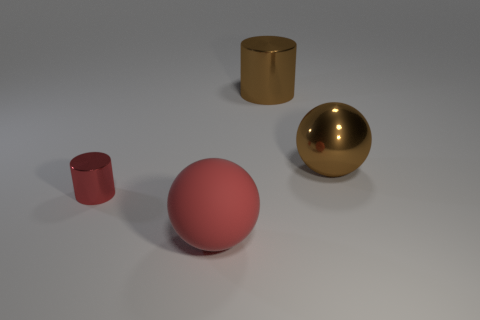Add 4 red spheres. How many objects exist? 8 Subtract all red cylinders. How many cylinders are left? 1 Subtract 1 cylinders. How many cylinders are left? 1 Subtract all brown spheres. Subtract all cyan blocks. How many spheres are left? 1 Subtract all green cylinders. How many green spheres are left? 0 Subtract all big purple objects. Subtract all red things. How many objects are left? 2 Add 1 big cylinders. How many big cylinders are left? 2 Add 1 yellow metal cylinders. How many yellow metal cylinders exist? 1 Subtract 0 green balls. How many objects are left? 4 